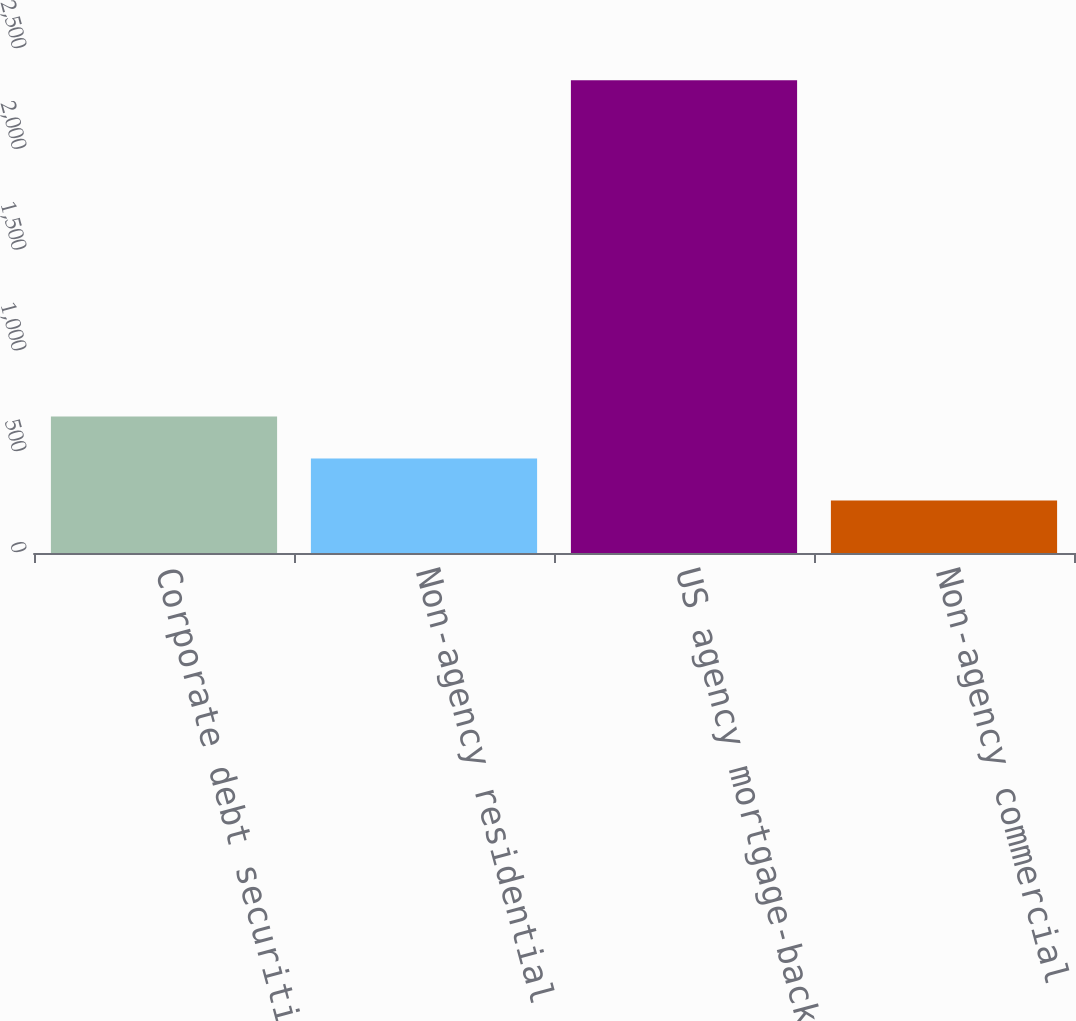Convert chart to OTSL. <chart><loc_0><loc_0><loc_500><loc_500><bar_chart><fcel>Corporate debt securities<fcel>Non-agency residential<fcel>US agency mortgage-backed<fcel>Non-agency commercial<nl><fcel>677<fcel>468.5<fcel>2345<fcel>260<nl></chart> 